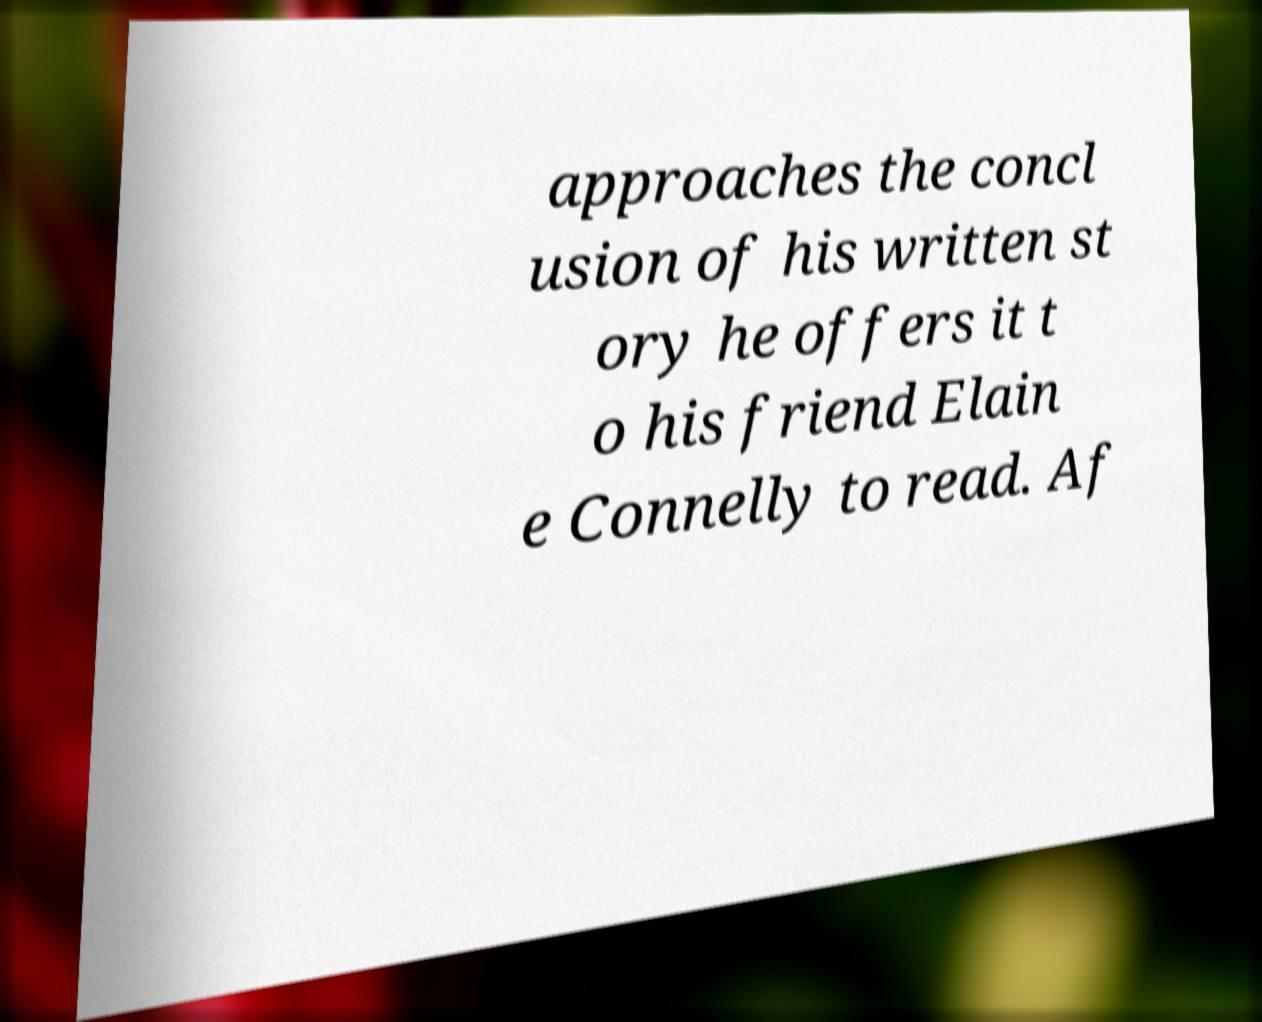Can you read and provide the text displayed in the image?This photo seems to have some interesting text. Can you extract and type it out for me? approaches the concl usion of his written st ory he offers it t o his friend Elain e Connelly to read. Af 